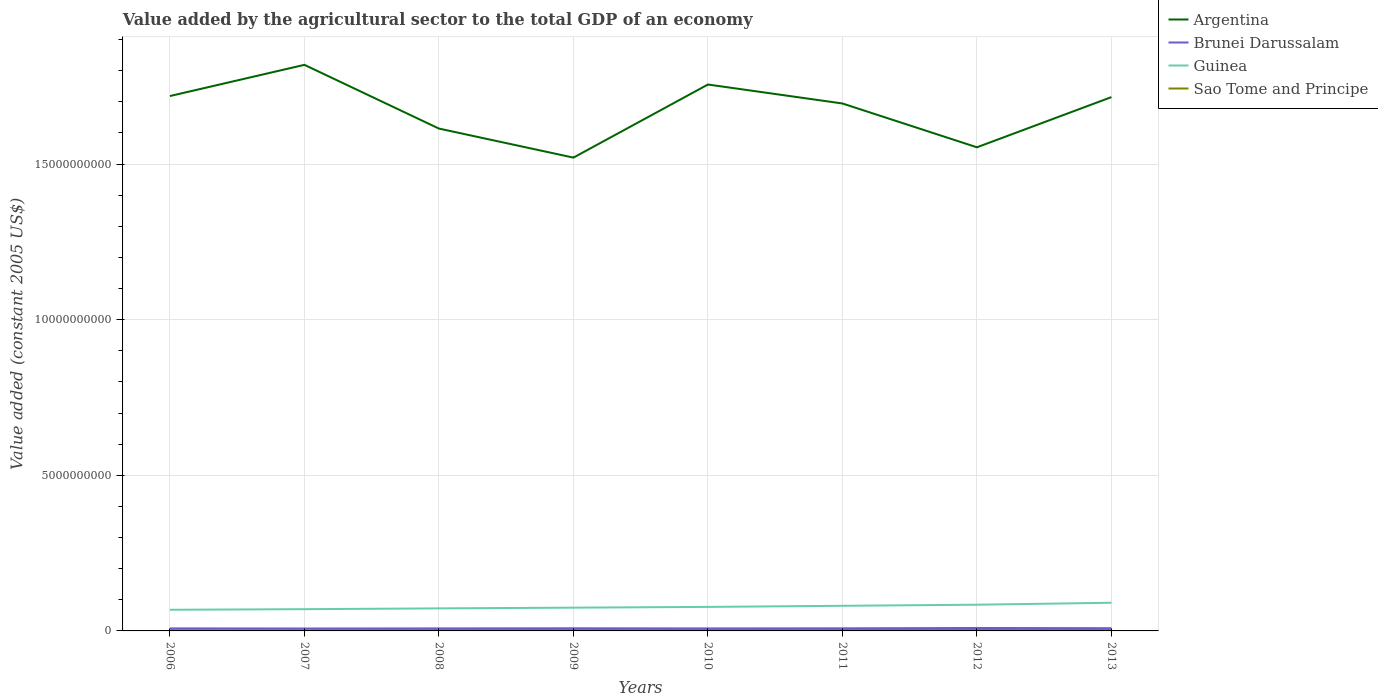Does the line corresponding to Argentina intersect with the line corresponding to Brunei Darussalam?
Keep it short and to the point. No. Across all years, what is the maximum value added by the agricultural sector in Argentina?
Make the answer very short. 1.52e+1. What is the total value added by the agricultural sector in Argentina in the graph?
Give a very brief answer. 1.04e+09. What is the difference between the highest and the second highest value added by the agricultural sector in Sao Tome and Principe?
Your response must be concise. 4.11e+06. How many lines are there?
Keep it short and to the point. 4. How many years are there in the graph?
Ensure brevity in your answer.  8. What is the difference between two consecutive major ticks on the Y-axis?
Your answer should be very brief. 5.00e+09. Are the values on the major ticks of Y-axis written in scientific E-notation?
Provide a succinct answer. No. How many legend labels are there?
Provide a short and direct response. 4. What is the title of the graph?
Provide a succinct answer. Value added by the agricultural sector to the total GDP of an economy. Does "Middle income" appear as one of the legend labels in the graph?
Provide a succinct answer. No. What is the label or title of the Y-axis?
Give a very brief answer. Value added (constant 2005 US$). What is the Value added (constant 2005 US$) in Argentina in 2006?
Give a very brief answer. 1.72e+1. What is the Value added (constant 2005 US$) in Brunei Darussalam in 2006?
Make the answer very short. 8.13e+07. What is the Value added (constant 2005 US$) of Guinea in 2006?
Make the answer very short. 6.80e+08. What is the Value added (constant 2005 US$) of Sao Tome and Principe in 2006?
Your answer should be very brief. 2.46e+07. What is the Value added (constant 2005 US$) in Argentina in 2007?
Offer a very short reply. 1.82e+1. What is the Value added (constant 2005 US$) of Brunei Darussalam in 2007?
Offer a very short reply. 7.77e+07. What is the Value added (constant 2005 US$) of Guinea in 2007?
Provide a short and direct response. 6.99e+08. What is the Value added (constant 2005 US$) of Sao Tome and Principe in 2007?
Offer a terse response. 2.53e+07. What is the Value added (constant 2005 US$) in Argentina in 2008?
Provide a succinct answer. 1.61e+1. What is the Value added (constant 2005 US$) in Brunei Darussalam in 2008?
Ensure brevity in your answer.  8.06e+07. What is the Value added (constant 2005 US$) in Guinea in 2008?
Keep it short and to the point. 7.24e+08. What is the Value added (constant 2005 US$) in Sao Tome and Principe in 2008?
Give a very brief answer. 2.75e+07. What is the Value added (constant 2005 US$) in Argentina in 2009?
Give a very brief answer. 1.52e+1. What is the Value added (constant 2005 US$) in Brunei Darussalam in 2009?
Ensure brevity in your answer.  8.52e+07. What is the Value added (constant 2005 US$) in Guinea in 2009?
Give a very brief answer. 7.48e+08. What is the Value added (constant 2005 US$) of Sao Tome and Principe in 2009?
Offer a very short reply. 2.85e+07. What is the Value added (constant 2005 US$) in Argentina in 2010?
Your answer should be compact. 1.76e+1. What is the Value added (constant 2005 US$) in Brunei Darussalam in 2010?
Give a very brief answer. 8.02e+07. What is the Value added (constant 2005 US$) in Guinea in 2010?
Your answer should be very brief. 7.71e+08. What is the Value added (constant 2005 US$) in Sao Tome and Principe in 2010?
Provide a succinct answer. 2.82e+07. What is the Value added (constant 2005 US$) of Argentina in 2011?
Provide a succinct answer. 1.69e+1. What is the Value added (constant 2005 US$) of Brunei Darussalam in 2011?
Your response must be concise. 8.39e+07. What is the Value added (constant 2005 US$) in Guinea in 2011?
Offer a terse response. 8.07e+08. What is the Value added (constant 2005 US$) of Sao Tome and Principe in 2011?
Keep it short and to the point. 2.85e+07. What is the Value added (constant 2005 US$) in Argentina in 2012?
Your answer should be compact. 1.55e+1. What is the Value added (constant 2005 US$) of Brunei Darussalam in 2012?
Provide a succinct answer. 9.38e+07. What is the Value added (constant 2005 US$) in Guinea in 2012?
Provide a succinct answer. 8.42e+08. What is the Value added (constant 2005 US$) of Sao Tome and Principe in 2012?
Provide a succinct answer. 2.85e+07. What is the Value added (constant 2005 US$) in Argentina in 2013?
Ensure brevity in your answer.  1.72e+1. What is the Value added (constant 2005 US$) of Brunei Darussalam in 2013?
Make the answer very short. 8.77e+07. What is the Value added (constant 2005 US$) of Guinea in 2013?
Ensure brevity in your answer.  9.05e+08. What is the Value added (constant 2005 US$) of Sao Tome and Principe in 2013?
Keep it short and to the point. 2.87e+07. Across all years, what is the maximum Value added (constant 2005 US$) in Argentina?
Give a very brief answer. 1.82e+1. Across all years, what is the maximum Value added (constant 2005 US$) in Brunei Darussalam?
Offer a very short reply. 9.38e+07. Across all years, what is the maximum Value added (constant 2005 US$) in Guinea?
Keep it short and to the point. 9.05e+08. Across all years, what is the maximum Value added (constant 2005 US$) of Sao Tome and Principe?
Provide a short and direct response. 2.87e+07. Across all years, what is the minimum Value added (constant 2005 US$) in Argentina?
Offer a very short reply. 1.52e+1. Across all years, what is the minimum Value added (constant 2005 US$) in Brunei Darussalam?
Offer a very short reply. 7.77e+07. Across all years, what is the minimum Value added (constant 2005 US$) of Guinea?
Provide a short and direct response. 6.80e+08. Across all years, what is the minimum Value added (constant 2005 US$) of Sao Tome and Principe?
Provide a succinct answer. 2.46e+07. What is the total Value added (constant 2005 US$) of Argentina in the graph?
Keep it short and to the point. 1.34e+11. What is the total Value added (constant 2005 US$) of Brunei Darussalam in the graph?
Provide a short and direct response. 6.70e+08. What is the total Value added (constant 2005 US$) in Guinea in the graph?
Keep it short and to the point. 6.18e+09. What is the total Value added (constant 2005 US$) of Sao Tome and Principe in the graph?
Give a very brief answer. 2.20e+08. What is the difference between the Value added (constant 2005 US$) of Argentina in 2006 and that in 2007?
Your response must be concise. -1.00e+09. What is the difference between the Value added (constant 2005 US$) in Brunei Darussalam in 2006 and that in 2007?
Provide a succinct answer. 3.63e+06. What is the difference between the Value added (constant 2005 US$) of Guinea in 2006 and that in 2007?
Provide a succinct answer. -1.90e+07. What is the difference between the Value added (constant 2005 US$) in Sao Tome and Principe in 2006 and that in 2007?
Provide a succinct answer. -6.63e+05. What is the difference between the Value added (constant 2005 US$) in Argentina in 2006 and that in 2008?
Make the answer very short. 1.05e+09. What is the difference between the Value added (constant 2005 US$) in Brunei Darussalam in 2006 and that in 2008?
Give a very brief answer. 7.27e+05. What is the difference between the Value added (constant 2005 US$) of Guinea in 2006 and that in 2008?
Give a very brief answer. -4.42e+07. What is the difference between the Value added (constant 2005 US$) of Sao Tome and Principe in 2006 and that in 2008?
Keep it short and to the point. -2.84e+06. What is the difference between the Value added (constant 2005 US$) in Argentina in 2006 and that in 2009?
Keep it short and to the point. 1.98e+09. What is the difference between the Value added (constant 2005 US$) of Brunei Darussalam in 2006 and that in 2009?
Your answer should be compact. -3.88e+06. What is the difference between the Value added (constant 2005 US$) of Guinea in 2006 and that in 2009?
Give a very brief answer. -6.76e+07. What is the difference between the Value added (constant 2005 US$) of Sao Tome and Principe in 2006 and that in 2009?
Your answer should be very brief. -3.91e+06. What is the difference between the Value added (constant 2005 US$) in Argentina in 2006 and that in 2010?
Your response must be concise. -3.70e+08. What is the difference between the Value added (constant 2005 US$) of Brunei Darussalam in 2006 and that in 2010?
Provide a short and direct response. 1.12e+06. What is the difference between the Value added (constant 2005 US$) in Guinea in 2006 and that in 2010?
Keep it short and to the point. -9.14e+07. What is the difference between the Value added (constant 2005 US$) in Sao Tome and Principe in 2006 and that in 2010?
Your response must be concise. -3.54e+06. What is the difference between the Value added (constant 2005 US$) of Argentina in 2006 and that in 2011?
Offer a very short reply. 2.39e+08. What is the difference between the Value added (constant 2005 US$) in Brunei Darussalam in 2006 and that in 2011?
Ensure brevity in your answer.  -2.54e+06. What is the difference between the Value added (constant 2005 US$) of Guinea in 2006 and that in 2011?
Provide a succinct answer. -1.27e+08. What is the difference between the Value added (constant 2005 US$) of Sao Tome and Principe in 2006 and that in 2011?
Offer a terse response. -3.83e+06. What is the difference between the Value added (constant 2005 US$) of Argentina in 2006 and that in 2012?
Your response must be concise. 1.65e+09. What is the difference between the Value added (constant 2005 US$) of Brunei Darussalam in 2006 and that in 2012?
Provide a short and direct response. -1.25e+07. What is the difference between the Value added (constant 2005 US$) of Guinea in 2006 and that in 2012?
Ensure brevity in your answer.  -1.62e+08. What is the difference between the Value added (constant 2005 US$) in Sao Tome and Principe in 2006 and that in 2012?
Your response must be concise. -3.83e+06. What is the difference between the Value added (constant 2005 US$) of Argentina in 2006 and that in 2013?
Your answer should be very brief. 3.43e+07. What is the difference between the Value added (constant 2005 US$) of Brunei Darussalam in 2006 and that in 2013?
Provide a short and direct response. -6.42e+06. What is the difference between the Value added (constant 2005 US$) in Guinea in 2006 and that in 2013?
Ensure brevity in your answer.  -2.25e+08. What is the difference between the Value added (constant 2005 US$) in Sao Tome and Principe in 2006 and that in 2013?
Make the answer very short. -4.11e+06. What is the difference between the Value added (constant 2005 US$) of Argentina in 2007 and that in 2008?
Ensure brevity in your answer.  2.05e+09. What is the difference between the Value added (constant 2005 US$) of Brunei Darussalam in 2007 and that in 2008?
Ensure brevity in your answer.  -2.91e+06. What is the difference between the Value added (constant 2005 US$) in Guinea in 2007 and that in 2008?
Your response must be concise. -2.52e+07. What is the difference between the Value added (constant 2005 US$) in Sao Tome and Principe in 2007 and that in 2008?
Keep it short and to the point. -2.17e+06. What is the difference between the Value added (constant 2005 US$) in Argentina in 2007 and that in 2009?
Ensure brevity in your answer.  2.98e+09. What is the difference between the Value added (constant 2005 US$) of Brunei Darussalam in 2007 and that in 2009?
Your answer should be compact. -7.51e+06. What is the difference between the Value added (constant 2005 US$) of Guinea in 2007 and that in 2009?
Provide a short and direct response. -4.85e+07. What is the difference between the Value added (constant 2005 US$) of Sao Tome and Principe in 2007 and that in 2009?
Keep it short and to the point. -3.25e+06. What is the difference between the Value added (constant 2005 US$) of Argentina in 2007 and that in 2010?
Your answer should be compact. 6.32e+08. What is the difference between the Value added (constant 2005 US$) of Brunei Darussalam in 2007 and that in 2010?
Offer a very short reply. -2.51e+06. What is the difference between the Value added (constant 2005 US$) of Guinea in 2007 and that in 2010?
Your answer should be very brief. -7.24e+07. What is the difference between the Value added (constant 2005 US$) in Sao Tome and Principe in 2007 and that in 2010?
Your answer should be very brief. -2.88e+06. What is the difference between the Value added (constant 2005 US$) of Argentina in 2007 and that in 2011?
Give a very brief answer. 1.24e+09. What is the difference between the Value added (constant 2005 US$) in Brunei Darussalam in 2007 and that in 2011?
Offer a terse response. -6.18e+06. What is the difference between the Value added (constant 2005 US$) of Guinea in 2007 and that in 2011?
Give a very brief answer. -1.08e+08. What is the difference between the Value added (constant 2005 US$) of Sao Tome and Principe in 2007 and that in 2011?
Give a very brief answer. -3.17e+06. What is the difference between the Value added (constant 2005 US$) of Argentina in 2007 and that in 2012?
Give a very brief answer. 2.65e+09. What is the difference between the Value added (constant 2005 US$) in Brunei Darussalam in 2007 and that in 2012?
Ensure brevity in your answer.  -1.61e+07. What is the difference between the Value added (constant 2005 US$) in Guinea in 2007 and that in 2012?
Offer a terse response. -1.43e+08. What is the difference between the Value added (constant 2005 US$) of Sao Tome and Principe in 2007 and that in 2012?
Your answer should be compact. -3.17e+06. What is the difference between the Value added (constant 2005 US$) in Argentina in 2007 and that in 2013?
Offer a terse response. 1.04e+09. What is the difference between the Value added (constant 2005 US$) in Brunei Darussalam in 2007 and that in 2013?
Make the answer very short. -1.01e+07. What is the difference between the Value added (constant 2005 US$) in Guinea in 2007 and that in 2013?
Give a very brief answer. -2.06e+08. What is the difference between the Value added (constant 2005 US$) in Sao Tome and Principe in 2007 and that in 2013?
Offer a terse response. -3.44e+06. What is the difference between the Value added (constant 2005 US$) of Argentina in 2008 and that in 2009?
Your answer should be very brief. 9.33e+08. What is the difference between the Value added (constant 2005 US$) of Brunei Darussalam in 2008 and that in 2009?
Your answer should be very brief. -4.60e+06. What is the difference between the Value added (constant 2005 US$) in Guinea in 2008 and that in 2009?
Keep it short and to the point. -2.34e+07. What is the difference between the Value added (constant 2005 US$) in Sao Tome and Principe in 2008 and that in 2009?
Keep it short and to the point. -1.07e+06. What is the difference between the Value added (constant 2005 US$) in Argentina in 2008 and that in 2010?
Your answer should be very brief. -1.42e+09. What is the difference between the Value added (constant 2005 US$) of Brunei Darussalam in 2008 and that in 2010?
Your response must be concise. 3.92e+05. What is the difference between the Value added (constant 2005 US$) in Guinea in 2008 and that in 2010?
Your answer should be compact. -4.72e+07. What is the difference between the Value added (constant 2005 US$) in Sao Tome and Principe in 2008 and that in 2010?
Your response must be concise. -7.05e+05. What is the difference between the Value added (constant 2005 US$) of Argentina in 2008 and that in 2011?
Give a very brief answer. -8.06e+08. What is the difference between the Value added (constant 2005 US$) in Brunei Darussalam in 2008 and that in 2011?
Your response must be concise. -3.27e+06. What is the difference between the Value added (constant 2005 US$) of Guinea in 2008 and that in 2011?
Ensure brevity in your answer.  -8.32e+07. What is the difference between the Value added (constant 2005 US$) of Sao Tome and Principe in 2008 and that in 2011?
Provide a succinct answer. -9.98e+05. What is the difference between the Value added (constant 2005 US$) in Argentina in 2008 and that in 2012?
Provide a succinct answer. 6.02e+08. What is the difference between the Value added (constant 2005 US$) of Brunei Darussalam in 2008 and that in 2012?
Offer a very short reply. -1.32e+07. What is the difference between the Value added (constant 2005 US$) of Guinea in 2008 and that in 2012?
Your response must be concise. -1.18e+08. What is the difference between the Value added (constant 2005 US$) of Sao Tome and Principe in 2008 and that in 2012?
Make the answer very short. -9.93e+05. What is the difference between the Value added (constant 2005 US$) in Argentina in 2008 and that in 2013?
Your answer should be very brief. -1.01e+09. What is the difference between the Value added (constant 2005 US$) of Brunei Darussalam in 2008 and that in 2013?
Make the answer very short. -7.15e+06. What is the difference between the Value added (constant 2005 US$) in Guinea in 2008 and that in 2013?
Ensure brevity in your answer.  -1.81e+08. What is the difference between the Value added (constant 2005 US$) in Sao Tome and Principe in 2008 and that in 2013?
Make the answer very short. -1.27e+06. What is the difference between the Value added (constant 2005 US$) in Argentina in 2009 and that in 2010?
Give a very brief answer. -2.35e+09. What is the difference between the Value added (constant 2005 US$) in Brunei Darussalam in 2009 and that in 2010?
Offer a terse response. 4.99e+06. What is the difference between the Value added (constant 2005 US$) in Guinea in 2009 and that in 2010?
Provide a short and direct response. -2.39e+07. What is the difference between the Value added (constant 2005 US$) of Sao Tome and Principe in 2009 and that in 2010?
Provide a succinct answer. 3.67e+05. What is the difference between the Value added (constant 2005 US$) in Argentina in 2009 and that in 2011?
Offer a terse response. -1.74e+09. What is the difference between the Value added (constant 2005 US$) of Brunei Darussalam in 2009 and that in 2011?
Your response must be concise. 1.33e+06. What is the difference between the Value added (constant 2005 US$) of Guinea in 2009 and that in 2011?
Offer a terse response. -5.98e+07. What is the difference between the Value added (constant 2005 US$) in Sao Tome and Principe in 2009 and that in 2011?
Make the answer very short. 7.39e+04. What is the difference between the Value added (constant 2005 US$) of Argentina in 2009 and that in 2012?
Provide a short and direct response. -3.31e+08. What is the difference between the Value added (constant 2005 US$) in Brunei Darussalam in 2009 and that in 2012?
Give a very brief answer. -8.60e+06. What is the difference between the Value added (constant 2005 US$) of Guinea in 2009 and that in 2012?
Provide a short and direct response. -9.49e+07. What is the difference between the Value added (constant 2005 US$) of Sao Tome and Principe in 2009 and that in 2012?
Your answer should be compact. 7.86e+04. What is the difference between the Value added (constant 2005 US$) in Argentina in 2009 and that in 2013?
Your response must be concise. -1.94e+09. What is the difference between the Value added (constant 2005 US$) of Brunei Darussalam in 2009 and that in 2013?
Offer a terse response. -2.54e+06. What is the difference between the Value added (constant 2005 US$) of Guinea in 2009 and that in 2013?
Provide a succinct answer. -1.57e+08. What is the difference between the Value added (constant 2005 US$) of Sao Tome and Principe in 2009 and that in 2013?
Your response must be concise. -1.99e+05. What is the difference between the Value added (constant 2005 US$) in Argentina in 2010 and that in 2011?
Your response must be concise. 6.09e+08. What is the difference between the Value added (constant 2005 US$) of Brunei Darussalam in 2010 and that in 2011?
Your answer should be compact. -3.66e+06. What is the difference between the Value added (constant 2005 US$) in Guinea in 2010 and that in 2011?
Provide a short and direct response. -3.59e+07. What is the difference between the Value added (constant 2005 US$) of Sao Tome and Principe in 2010 and that in 2011?
Make the answer very short. -2.93e+05. What is the difference between the Value added (constant 2005 US$) of Argentina in 2010 and that in 2012?
Ensure brevity in your answer.  2.02e+09. What is the difference between the Value added (constant 2005 US$) of Brunei Darussalam in 2010 and that in 2012?
Your answer should be very brief. -1.36e+07. What is the difference between the Value added (constant 2005 US$) in Guinea in 2010 and that in 2012?
Offer a terse response. -7.10e+07. What is the difference between the Value added (constant 2005 US$) of Sao Tome and Principe in 2010 and that in 2012?
Ensure brevity in your answer.  -2.89e+05. What is the difference between the Value added (constant 2005 US$) of Argentina in 2010 and that in 2013?
Your answer should be very brief. 4.05e+08. What is the difference between the Value added (constant 2005 US$) of Brunei Darussalam in 2010 and that in 2013?
Keep it short and to the point. -7.54e+06. What is the difference between the Value added (constant 2005 US$) in Guinea in 2010 and that in 2013?
Make the answer very short. -1.34e+08. What is the difference between the Value added (constant 2005 US$) of Sao Tome and Principe in 2010 and that in 2013?
Offer a very short reply. -5.66e+05. What is the difference between the Value added (constant 2005 US$) of Argentina in 2011 and that in 2012?
Provide a succinct answer. 1.41e+09. What is the difference between the Value added (constant 2005 US$) in Brunei Darussalam in 2011 and that in 2012?
Make the answer very short. -9.93e+06. What is the difference between the Value added (constant 2005 US$) in Guinea in 2011 and that in 2012?
Your answer should be compact. -3.51e+07. What is the difference between the Value added (constant 2005 US$) in Sao Tome and Principe in 2011 and that in 2012?
Give a very brief answer. 4665.81. What is the difference between the Value added (constant 2005 US$) of Argentina in 2011 and that in 2013?
Keep it short and to the point. -2.05e+08. What is the difference between the Value added (constant 2005 US$) in Brunei Darussalam in 2011 and that in 2013?
Offer a terse response. -3.88e+06. What is the difference between the Value added (constant 2005 US$) of Guinea in 2011 and that in 2013?
Ensure brevity in your answer.  -9.76e+07. What is the difference between the Value added (constant 2005 US$) in Sao Tome and Principe in 2011 and that in 2013?
Your answer should be compact. -2.73e+05. What is the difference between the Value added (constant 2005 US$) of Argentina in 2012 and that in 2013?
Your answer should be very brief. -1.61e+09. What is the difference between the Value added (constant 2005 US$) of Brunei Darussalam in 2012 and that in 2013?
Provide a succinct answer. 6.06e+06. What is the difference between the Value added (constant 2005 US$) in Guinea in 2012 and that in 2013?
Offer a very short reply. -6.25e+07. What is the difference between the Value added (constant 2005 US$) in Sao Tome and Principe in 2012 and that in 2013?
Give a very brief answer. -2.78e+05. What is the difference between the Value added (constant 2005 US$) of Argentina in 2006 and the Value added (constant 2005 US$) of Brunei Darussalam in 2007?
Make the answer very short. 1.71e+1. What is the difference between the Value added (constant 2005 US$) of Argentina in 2006 and the Value added (constant 2005 US$) of Guinea in 2007?
Your answer should be very brief. 1.65e+1. What is the difference between the Value added (constant 2005 US$) of Argentina in 2006 and the Value added (constant 2005 US$) of Sao Tome and Principe in 2007?
Offer a terse response. 1.72e+1. What is the difference between the Value added (constant 2005 US$) in Brunei Darussalam in 2006 and the Value added (constant 2005 US$) in Guinea in 2007?
Provide a short and direct response. -6.18e+08. What is the difference between the Value added (constant 2005 US$) of Brunei Darussalam in 2006 and the Value added (constant 2005 US$) of Sao Tome and Principe in 2007?
Ensure brevity in your answer.  5.60e+07. What is the difference between the Value added (constant 2005 US$) in Guinea in 2006 and the Value added (constant 2005 US$) in Sao Tome and Principe in 2007?
Keep it short and to the point. 6.55e+08. What is the difference between the Value added (constant 2005 US$) of Argentina in 2006 and the Value added (constant 2005 US$) of Brunei Darussalam in 2008?
Provide a short and direct response. 1.71e+1. What is the difference between the Value added (constant 2005 US$) of Argentina in 2006 and the Value added (constant 2005 US$) of Guinea in 2008?
Your response must be concise. 1.65e+1. What is the difference between the Value added (constant 2005 US$) in Argentina in 2006 and the Value added (constant 2005 US$) in Sao Tome and Principe in 2008?
Your answer should be very brief. 1.72e+1. What is the difference between the Value added (constant 2005 US$) of Brunei Darussalam in 2006 and the Value added (constant 2005 US$) of Guinea in 2008?
Your answer should be very brief. -6.43e+08. What is the difference between the Value added (constant 2005 US$) of Brunei Darussalam in 2006 and the Value added (constant 2005 US$) of Sao Tome and Principe in 2008?
Ensure brevity in your answer.  5.39e+07. What is the difference between the Value added (constant 2005 US$) in Guinea in 2006 and the Value added (constant 2005 US$) in Sao Tome and Principe in 2008?
Your answer should be compact. 6.53e+08. What is the difference between the Value added (constant 2005 US$) in Argentina in 2006 and the Value added (constant 2005 US$) in Brunei Darussalam in 2009?
Your answer should be very brief. 1.71e+1. What is the difference between the Value added (constant 2005 US$) of Argentina in 2006 and the Value added (constant 2005 US$) of Guinea in 2009?
Your response must be concise. 1.64e+1. What is the difference between the Value added (constant 2005 US$) of Argentina in 2006 and the Value added (constant 2005 US$) of Sao Tome and Principe in 2009?
Your answer should be very brief. 1.72e+1. What is the difference between the Value added (constant 2005 US$) of Brunei Darussalam in 2006 and the Value added (constant 2005 US$) of Guinea in 2009?
Your answer should be very brief. -6.66e+08. What is the difference between the Value added (constant 2005 US$) in Brunei Darussalam in 2006 and the Value added (constant 2005 US$) in Sao Tome and Principe in 2009?
Provide a short and direct response. 5.28e+07. What is the difference between the Value added (constant 2005 US$) in Guinea in 2006 and the Value added (constant 2005 US$) in Sao Tome and Principe in 2009?
Provide a succinct answer. 6.51e+08. What is the difference between the Value added (constant 2005 US$) of Argentina in 2006 and the Value added (constant 2005 US$) of Brunei Darussalam in 2010?
Your response must be concise. 1.71e+1. What is the difference between the Value added (constant 2005 US$) in Argentina in 2006 and the Value added (constant 2005 US$) in Guinea in 2010?
Provide a short and direct response. 1.64e+1. What is the difference between the Value added (constant 2005 US$) of Argentina in 2006 and the Value added (constant 2005 US$) of Sao Tome and Principe in 2010?
Keep it short and to the point. 1.72e+1. What is the difference between the Value added (constant 2005 US$) of Brunei Darussalam in 2006 and the Value added (constant 2005 US$) of Guinea in 2010?
Offer a very short reply. -6.90e+08. What is the difference between the Value added (constant 2005 US$) in Brunei Darussalam in 2006 and the Value added (constant 2005 US$) in Sao Tome and Principe in 2010?
Ensure brevity in your answer.  5.32e+07. What is the difference between the Value added (constant 2005 US$) in Guinea in 2006 and the Value added (constant 2005 US$) in Sao Tome and Principe in 2010?
Make the answer very short. 6.52e+08. What is the difference between the Value added (constant 2005 US$) of Argentina in 2006 and the Value added (constant 2005 US$) of Brunei Darussalam in 2011?
Offer a terse response. 1.71e+1. What is the difference between the Value added (constant 2005 US$) of Argentina in 2006 and the Value added (constant 2005 US$) of Guinea in 2011?
Give a very brief answer. 1.64e+1. What is the difference between the Value added (constant 2005 US$) of Argentina in 2006 and the Value added (constant 2005 US$) of Sao Tome and Principe in 2011?
Provide a short and direct response. 1.72e+1. What is the difference between the Value added (constant 2005 US$) in Brunei Darussalam in 2006 and the Value added (constant 2005 US$) in Guinea in 2011?
Your answer should be compact. -7.26e+08. What is the difference between the Value added (constant 2005 US$) of Brunei Darussalam in 2006 and the Value added (constant 2005 US$) of Sao Tome and Principe in 2011?
Your answer should be very brief. 5.29e+07. What is the difference between the Value added (constant 2005 US$) in Guinea in 2006 and the Value added (constant 2005 US$) in Sao Tome and Principe in 2011?
Give a very brief answer. 6.52e+08. What is the difference between the Value added (constant 2005 US$) of Argentina in 2006 and the Value added (constant 2005 US$) of Brunei Darussalam in 2012?
Give a very brief answer. 1.71e+1. What is the difference between the Value added (constant 2005 US$) in Argentina in 2006 and the Value added (constant 2005 US$) in Guinea in 2012?
Offer a terse response. 1.63e+1. What is the difference between the Value added (constant 2005 US$) in Argentina in 2006 and the Value added (constant 2005 US$) in Sao Tome and Principe in 2012?
Provide a short and direct response. 1.72e+1. What is the difference between the Value added (constant 2005 US$) in Brunei Darussalam in 2006 and the Value added (constant 2005 US$) in Guinea in 2012?
Offer a terse response. -7.61e+08. What is the difference between the Value added (constant 2005 US$) in Brunei Darussalam in 2006 and the Value added (constant 2005 US$) in Sao Tome and Principe in 2012?
Provide a short and direct response. 5.29e+07. What is the difference between the Value added (constant 2005 US$) in Guinea in 2006 and the Value added (constant 2005 US$) in Sao Tome and Principe in 2012?
Your response must be concise. 6.52e+08. What is the difference between the Value added (constant 2005 US$) in Argentina in 2006 and the Value added (constant 2005 US$) in Brunei Darussalam in 2013?
Your response must be concise. 1.71e+1. What is the difference between the Value added (constant 2005 US$) in Argentina in 2006 and the Value added (constant 2005 US$) in Guinea in 2013?
Provide a short and direct response. 1.63e+1. What is the difference between the Value added (constant 2005 US$) of Argentina in 2006 and the Value added (constant 2005 US$) of Sao Tome and Principe in 2013?
Your answer should be compact. 1.72e+1. What is the difference between the Value added (constant 2005 US$) of Brunei Darussalam in 2006 and the Value added (constant 2005 US$) of Guinea in 2013?
Give a very brief answer. -8.24e+08. What is the difference between the Value added (constant 2005 US$) of Brunei Darussalam in 2006 and the Value added (constant 2005 US$) of Sao Tome and Principe in 2013?
Offer a terse response. 5.26e+07. What is the difference between the Value added (constant 2005 US$) of Guinea in 2006 and the Value added (constant 2005 US$) of Sao Tome and Principe in 2013?
Give a very brief answer. 6.51e+08. What is the difference between the Value added (constant 2005 US$) in Argentina in 2007 and the Value added (constant 2005 US$) in Brunei Darussalam in 2008?
Make the answer very short. 1.81e+1. What is the difference between the Value added (constant 2005 US$) of Argentina in 2007 and the Value added (constant 2005 US$) of Guinea in 2008?
Your answer should be compact. 1.75e+1. What is the difference between the Value added (constant 2005 US$) in Argentina in 2007 and the Value added (constant 2005 US$) in Sao Tome and Principe in 2008?
Your answer should be compact. 1.82e+1. What is the difference between the Value added (constant 2005 US$) in Brunei Darussalam in 2007 and the Value added (constant 2005 US$) in Guinea in 2008?
Offer a terse response. -6.46e+08. What is the difference between the Value added (constant 2005 US$) in Brunei Darussalam in 2007 and the Value added (constant 2005 US$) in Sao Tome and Principe in 2008?
Make the answer very short. 5.02e+07. What is the difference between the Value added (constant 2005 US$) of Guinea in 2007 and the Value added (constant 2005 US$) of Sao Tome and Principe in 2008?
Give a very brief answer. 6.72e+08. What is the difference between the Value added (constant 2005 US$) in Argentina in 2007 and the Value added (constant 2005 US$) in Brunei Darussalam in 2009?
Your answer should be very brief. 1.81e+1. What is the difference between the Value added (constant 2005 US$) in Argentina in 2007 and the Value added (constant 2005 US$) in Guinea in 2009?
Provide a short and direct response. 1.74e+1. What is the difference between the Value added (constant 2005 US$) in Argentina in 2007 and the Value added (constant 2005 US$) in Sao Tome and Principe in 2009?
Provide a succinct answer. 1.82e+1. What is the difference between the Value added (constant 2005 US$) in Brunei Darussalam in 2007 and the Value added (constant 2005 US$) in Guinea in 2009?
Your response must be concise. -6.70e+08. What is the difference between the Value added (constant 2005 US$) in Brunei Darussalam in 2007 and the Value added (constant 2005 US$) in Sao Tome and Principe in 2009?
Make the answer very short. 4.92e+07. What is the difference between the Value added (constant 2005 US$) of Guinea in 2007 and the Value added (constant 2005 US$) of Sao Tome and Principe in 2009?
Ensure brevity in your answer.  6.70e+08. What is the difference between the Value added (constant 2005 US$) in Argentina in 2007 and the Value added (constant 2005 US$) in Brunei Darussalam in 2010?
Give a very brief answer. 1.81e+1. What is the difference between the Value added (constant 2005 US$) in Argentina in 2007 and the Value added (constant 2005 US$) in Guinea in 2010?
Your response must be concise. 1.74e+1. What is the difference between the Value added (constant 2005 US$) in Argentina in 2007 and the Value added (constant 2005 US$) in Sao Tome and Principe in 2010?
Make the answer very short. 1.82e+1. What is the difference between the Value added (constant 2005 US$) of Brunei Darussalam in 2007 and the Value added (constant 2005 US$) of Guinea in 2010?
Offer a terse response. -6.94e+08. What is the difference between the Value added (constant 2005 US$) of Brunei Darussalam in 2007 and the Value added (constant 2005 US$) of Sao Tome and Principe in 2010?
Make the answer very short. 4.95e+07. What is the difference between the Value added (constant 2005 US$) of Guinea in 2007 and the Value added (constant 2005 US$) of Sao Tome and Principe in 2010?
Ensure brevity in your answer.  6.71e+08. What is the difference between the Value added (constant 2005 US$) in Argentina in 2007 and the Value added (constant 2005 US$) in Brunei Darussalam in 2011?
Provide a short and direct response. 1.81e+1. What is the difference between the Value added (constant 2005 US$) in Argentina in 2007 and the Value added (constant 2005 US$) in Guinea in 2011?
Your answer should be very brief. 1.74e+1. What is the difference between the Value added (constant 2005 US$) in Argentina in 2007 and the Value added (constant 2005 US$) in Sao Tome and Principe in 2011?
Make the answer very short. 1.82e+1. What is the difference between the Value added (constant 2005 US$) in Brunei Darussalam in 2007 and the Value added (constant 2005 US$) in Guinea in 2011?
Offer a very short reply. -7.30e+08. What is the difference between the Value added (constant 2005 US$) of Brunei Darussalam in 2007 and the Value added (constant 2005 US$) of Sao Tome and Principe in 2011?
Ensure brevity in your answer.  4.92e+07. What is the difference between the Value added (constant 2005 US$) of Guinea in 2007 and the Value added (constant 2005 US$) of Sao Tome and Principe in 2011?
Provide a short and direct response. 6.71e+08. What is the difference between the Value added (constant 2005 US$) in Argentina in 2007 and the Value added (constant 2005 US$) in Brunei Darussalam in 2012?
Your response must be concise. 1.81e+1. What is the difference between the Value added (constant 2005 US$) of Argentina in 2007 and the Value added (constant 2005 US$) of Guinea in 2012?
Give a very brief answer. 1.73e+1. What is the difference between the Value added (constant 2005 US$) of Argentina in 2007 and the Value added (constant 2005 US$) of Sao Tome and Principe in 2012?
Provide a short and direct response. 1.82e+1. What is the difference between the Value added (constant 2005 US$) in Brunei Darussalam in 2007 and the Value added (constant 2005 US$) in Guinea in 2012?
Provide a short and direct response. -7.65e+08. What is the difference between the Value added (constant 2005 US$) in Brunei Darussalam in 2007 and the Value added (constant 2005 US$) in Sao Tome and Principe in 2012?
Make the answer very short. 4.92e+07. What is the difference between the Value added (constant 2005 US$) of Guinea in 2007 and the Value added (constant 2005 US$) of Sao Tome and Principe in 2012?
Offer a very short reply. 6.71e+08. What is the difference between the Value added (constant 2005 US$) in Argentina in 2007 and the Value added (constant 2005 US$) in Brunei Darussalam in 2013?
Offer a terse response. 1.81e+1. What is the difference between the Value added (constant 2005 US$) of Argentina in 2007 and the Value added (constant 2005 US$) of Guinea in 2013?
Make the answer very short. 1.73e+1. What is the difference between the Value added (constant 2005 US$) in Argentina in 2007 and the Value added (constant 2005 US$) in Sao Tome and Principe in 2013?
Provide a short and direct response. 1.82e+1. What is the difference between the Value added (constant 2005 US$) in Brunei Darussalam in 2007 and the Value added (constant 2005 US$) in Guinea in 2013?
Make the answer very short. -8.27e+08. What is the difference between the Value added (constant 2005 US$) in Brunei Darussalam in 2007 and the Value added (constant 2005 US$) in Sao Tome and Principe in 2013?
Provide a succinct answer. 4.90e+07. What is the difference between the Value added (constant 2005 US$) in Guinea in 2007 and the Value added (constant 2005 US$) in Sao Tome and Principe in 2013?
Your answer should be compact. 6.70e+08. What is the difference between the Value added (constant 2005 US$) of Argentina in 2008 and the Value added (constant 2005 US$) of Brunei Darussalam in 2009?
Your answer should be very brief. 1.61e+1. What is the difference between the Value added (constant 2005 US$) of Argentina in 2008 and the Value added (constant 2005 US$) of Guinea in 2009?
Make the answer very short. 1.54e+1. What is the difference between the Value added (constant 2005 US$) of Argentina in 2008 and the Value added (constant 2005 US$) of Sao Tome and Principe in 2009?
Your answer should be compact. 1.61e+1. What is the difference between the Value added (constant 2005 US$) of Brunei Darussalam in 2008 and the Value added (constant 2005 US$) of Guinea in 2009?
Make the answer very short. -6.67e+08. What is the difference between the Value added (constant 2005 US$) in Brunei Darussalam in 2008 and the Value added (constant 2005 US$) in Sao Tome and Principe in 2009?
Keep it short and to the point. 5.21e+07. What is the difference between the Value added (constant 2005 US$) of Guinea in 2008 and the Value added (constant 2005 US$) of Sao Tome and Principe in 2009?
Your answer should be compact. 6.96e+08. What is the difference between the Value added (constant 2005 US$) in Argentina in 2008 and the Value added (constant 2005 US$) in Brunei Darussalam in 2010?
Offer a terse response. 1.61e+1. What is the difference between the Value added (constant 2005 US$) in Argentina in 2008 and the Value added (constant 2005 US$) in Guinea in 2010?
Your answer should be very brief. 1.54e+1. What is the difference between the Value added (constant 2005 US$) in Argentina in 2008 and the Value added (constant 2005 US$) in Sao Tome and Principe in 2010?
Your answer should be very brief. 1.61e+1. What is the difference between the Value added (constant 2005 US$) of Brunei Darussalam in 2008 and the Value added (constant 2005 US$) of Guinea in 2010?
Ensure brevity in your answer.  -6.91e+08. What is the difference between the Value added (constant 2005 US$) of Brunei Darussalam in 2008 and the Value added (constant 2005 US$) of Sao Tome and Principe in 2010?
Provide a succinct answer. 5.24e+07. What is the difference between the Value added (constant 2005 US$) of Guinea in 2008 and the Value added (constant 2005 US$) of Sao Tome and Principe in 2010?
Provide a succinct answer. 6.96e+08. What is the difference between the Value added (constant 2005 US$) of Argentina in 2008 and the Value added (constant 2005 US$) of Brunei Darussalam in 2011?
Provide a short and direct response. 1.61e+1. What is the difference between the Value added (constant 2005 US$) in Argentina in 2008 and the Value added (constant 2005 US$) in Guinea in 2011?
Offer a very short reply. 1.53e+1. What is the difference between the Value added (constant 2005 US$) of Argentina in 2008 and the Value added (constant 2005 US$) of Sao Tome and Principe in 2011?
Offer a very short reply. 1.61e+1. What is the difference between the Value added (constant 2005 US$) in Brunei Darussalam in 2008 and the Value added (constant 2005 US$) in Guinea in 2011?
Offer a terse response. -7.27e+08. What is the difference between the Value added (constant 2005 US$) in Brunei Darussalam in 2008 and the Value added (constant 2005 US$) in Sao Tome and Principe in 2011?
Ensure brevity in your answer.  5.21e+07. What is the difference between the Value added (constant 2005 US$) in Guinea in 2008 and the Value added (constant 2005 US$) in Sao Tome and Principe in 2011?
Provide a short and direct response. 6.96e+08. What is the difference between the Value added (constant 2005 US$) in Argentina in 2008 and the Value added (constant 2005 US$) in Brunei Darussalam in 2012?
Give a very brief answer. 1.60e+1. What is the difference between the Value added (constant 2005 US$) of Argentina in 2008 and the Value added (constant 2005 US$) of Guinea in 2012?
Provide a short and direct response. 1.53e+1. What is the difference between the Value added (constant 2005 US$) of Argentina in 2008 and the Value added (constant 2005 US$) of Sao Tome and Principe in 2012?
Provide a succinct answer. 1.61e+1. What is the difference between the Value added (constant 2005 US$) of Brunei Darussalam in 2008 and the Value added (constant 2005 US$) of Guinea in 2012?
Your answer should be very brief. -7.62e+08. What is the difference between the Value added (constant 2005 US$) of Brunei Darussalam in 2008 and the Value added (constant 2005 US$) of Sao Tome and Principe in 2012?
Your answer should be very brief. 5.21e+07. What is the difference between the Value added (constant 2005 US$) in Guinea in 2008 and the Value added (constant 2005 US$) in Sao Tome and Principe in 2012?
Provide a short and direct response. 6.96e+08. What is the difference between the Value added (constant 2005 US$) in Argentina in 2008 and the Value added (constant 2005 US$) in Brunei Darussalam in 2013?
Your answer should be compact. 1.61e+1. What is the difference between the Value added (constant 2005 US$) of Argentina in 2008 and the Value added (constant 2005 US$) of Guinea in 2013?
Ensure brevity in your answer.  1.52e+1. What is the difference between the Value added (constant 2005 US$) in Argentina in 2008 and the Value added (constant 2005 US$) in Sao Tome and Principe in 2013?
Make the answer very short. 1.61e+1. What is the difference between the Value added (constant 2005 US$) in Brunei Darussalam in 2008 and the Value added (constant 2005 US$) in Guinea in 2013?
Give a very brief answer. -8.24e+08. What is the difference between the Value added (constant 2005 US$) in Brunei Darussalam in 2008 and the Value added (constant 2005 US$) in Sao Tome and Principe in 2013?
Ensure brevity in your answer.  5.19e+07. What is the difference between the Value added (constant 2005 US$) of Guinea in 2008 and the Value added (constant 2005 US$) of Sao Tome and Principe in 2013?
Your answer should be very brief. 6.95e+08. What is the difference between the Value added (constant 2005 US$) in Argentina in 2009 and the Value added (constant 2005 US$) in Brunei Darussalam in 2010?
Your answer should be very brief. 1.51e+1. What is the difference between the Value added (constant 2005 US$) of Argentina in 2009 and the Value added (constant 2005 US$) of Guinea in 2010?
Provide a succinct answer. 1.44e+1. What is the difference between the Value added (constant 2005 US$) in Argentina in 2009 and the Value added (constant 2005 US$) in Sao Tome and Principe in 2010?
Offer a very short reply. 1.52e+1. What is the difference between the Value added (constant 2005 US$) of Brunei Darussalam in 2009 and the Value added (constant 2005 US$) of Guinea in 2010?
Make the answer very short. -6.86e+08. What is the difference between the Value added (constant 2005 US$) in Brunei Darussalam in 2009 and the Value added (constant 2005 US$) in Sao Tome and Principe in 2010?
Offer a very short reply. 5.70e+07. What is the difference between the Value added (constant 2005 US$) of Guinea in 2009 and the Value added (constant 2005 US$) of Sao Tome and Principe in 2010?
Offer a very short reply. 7.19e+08. What is the difference between the Value added (constant 2005 US$) in Argentina in 2009 and the Value added (constant 2005 US$) in Brunei Darussalam in 2011?
Your answer should be very brief. 1.51e+1. What is the difference between the Value added (constant 2005 US$) of Argentina in 2009 and the Value added (constant 2005 US$) of Guinea in 2011?
Make the answer very short. 1.44e+1. What is the difference between the Value added (constant 2005 US$) of Argentina in 2009 and the Value added (constant 2005 US$) of Sao Tome and Principe in 2011?
Your response must be concise. 1.52e+1. What is the difference between the Value added (constant 2005 US$) of Brunei Darussalam in 2009 and the Value added (constant 2005 US$) of Guinea in 2011?
Your answer should be compact. -7.22e+08. What is the difference between the Value added (constant 2005 US$) of Brunei Darussalam in 2009 and the Value added (constant 2005 US$) of Sao Tome and Principe in 2011?
Offer a very short reply. 5.67e+07. What is the difference between the Value added (constant 2005 US$) in Guinea in 2009 and the Value added (constant 2005 US$) in Sao Tome and Principe in 2011?
Provide a succinct answer. 7.19e+08. What is the difference between the Value added (constant 2005 US$) in Argentina in 2009 and the Value added (constant 2005 US$) in Brunei Darussalam in 2012?
Your response must be concise. 1.51e+1. What is the difference between the Value added (constant 2005 US$) in Argentina in 2009 and the Value added (constant 2005 US$) in Guinea in 2012?
Ensure brevity in your answer.  1.44e+1. What is the difference between the Value added (constant 2005 US$) in Argentina in 2009 and the Value added (constant 2005 US$) in Sao Tome and Principe in 2012?
Your answer should be compact. 1.52e+1. What is the difference between the Value added (constant 2005 US$) of Brunei Darussalam in 2009 and the Value added (constant 2005 US$) of Guinea in 2012?
Make the answer very short. -7.57e+08. What is the difference between the Value added (constant 2005 US$) of Brunei Darussalam in 2009 and the Value added (constant 2005 US$) of Sao Tome and Principe in 2012?
Your response must be concise. 5.67e+07. What is the difference between the Value added (constant 2005 US$) of Guinea in 2009 and the Value added (constant 2005 US$) of Sao Tome and Principe in 2012?
Offer a terse response. 7.19e+08. What is the difference between the Value added (constant 2005 US$) of Argentina in 2009 and the Value added (constant 2005 US$) of Brunei Darussalam in 2013?
Your answer should be compact. 1.51e+1. What is the difference between the Value added (constant 2005 US$) in Argentina in 2009 and the Value added (constant 2005 US$) in Guinea in 2013?
Offer a very short reply. 1.43e+1. What is the difference between the Value added (constant 2005 US$) of Argentina in 2009 and the Value added (constant 2005 US$) of Sao Tome and Principe in 2013?
Make the answer very short. 1.52e+1. What is the difference between the Value added (constant 2005 US$) in Brunei Darussalam in 2009 and the Value added (constant 2005 US$) in Guinea in 2013?
Keep it short and to the point. -8.20e+08. What is the difference between the Value added (constant 2005 US$) in Brunei Darussalam in 2009 and the Value added (constant 2005 US$) in Sao Tome and Principe in 2013?
Your response must be concise. 5.65e+07. What is the difference between the Value added (constant 2005 US$) in Guinea in 2009 and the Value added (constant 2005 US$) in Sao Tome and Principe in 2013?
Your answer should be very brief. 7.19e+08. What is the difference between the Value added (constant 2005 US$) in Argentina in 2010 and the Value added (constant 2005 US$) in Brunei Darussalam in 2011?
Your answer should be very brief. 1.75e+1. What is the difference between the Value added (constant 2005 US$) in Argentina in 2010 and the Value added (constant 2005 US$) in Guinea in 2011?
Keep it short and to the point. 1.67e+1. What is the difference between the Value added (constant 2005 US$) of Argentina in 2010 and the Value added (constant 2005 US$) of Sao Tome and Principe in 2011?
Your answer should be compact. 1.75e+1. What is the difference between the Value added (constant 2005 US$) in Brunei Darussalam in 2010 and the Value added (constant 2005 US$) in Guinea in 2011?
Your response must be concise. -7.27e+08. What is the difference between the Value added (constant 2005 US$) in Brunei Darussalam in 2010 and the Value added (constant 2005 US$) in Sao Tome and Principe in 2011?
Ensure brevity in your answer.  5.17e+07. What is the difference between the Value added (constant 2005 US$) of Guinea in 2010 and the Value added (constant 2005 US$) of Sao Tome and Principe in 2011?
Provide a short and direct response. 7.43e+08. What is the difference between the Value added (constant 2005 US$) in Argentina in 2010 and the Value added (constant 2005 US$) in Brunei Darussalam in 2012?
Ensure brevity in your answer.  1.75e+1. What is the difference between the Value added (constant 2005 US$) in Argentina in 2010 and the Value added (constant 2005 US$) in Guinea in 2012?
Offer a terse response. 1.67e+1. What is the difference between the Value added (constant 2005 US$) in Argentina in 2010 and the Value added (constant 2005 US$) in Sao Tome and Principe in 2012?
Make the answer very short. 1.75e+1. What is the difference between the Value added (constant 2005 US$) of Brunei Darussalam in 2010 and the Value added (constant 2005 US$) of Guinea in 2012?
Your response must be concise. -7.62e+08. What is the difference between the Value added (constant 2005 US$) in Brunei Darussalam in 2010 and the Value added (constant 2005 US$) in Sao Tome and Principe in 2012?
Ensure brevity in your answer.  5.17e+07. What is the difference between the Value added (constant 2005 US$) of Guinea in 2010 and the Value added (constant 2005 US$) of Sao Tome and Principe in 2012?
Give a very brief answer. 7.43e+08. What is the difference between the Value added (constant 2005 US$) in Argentina in 2010 and the Value added (constant 2005 US$) in Brunei Darussalam in 2013?
Offer a very short reply. 1.75e+1. What is the difference between the Value added (constant 2005 US$) in Argentina in 2010 and the Value added (constant 2005 US$) in Guinea in 2013?
Provide a short and direct response. 1.67e+1. What is the difference between the Value added (constant 2005 US$) of Argentina in 2010 and the Value added (constant 2005 US$) of Sao Tome and Principe in 2013?
Your answer should be compact. 1.75e+1. What is the difference between the Value added (constant 2005 US$) of Brunei Darussalam in 2010 and the Value added (constant 2005 US$) of Guinea in 2013?
Make the answer very short. -8.25e+08. What is the difference between the Value added (constant 2005 US$) in Brunei Darussalam in 2010 and the Value added (constant 2005 US$) in Sao Tome and Principe in 2013?
Keep it short and to the point. 5.15e+07. What is the difference between the Value added (constant 2005 US$) in Guinea in 2010 and the Value added (constant 2005 US$) in Sao Tome and Principe in 2013?
Ensure brevity in your answer.  7.43e+08. What is the difference between the Value added (constant 2005 US$) in Argentina in 2011 and the Value added (constant 2005 US$) in Brunei Darussalam in 2012?
Keep it short and to the point. 1.69e+1. What is the difference between the Value added (constant 2005 US$) in Argentina in 2011 and the Value added (constant 2005 US$) in Guinea in 2012?
Make the answer very short. 1.61e+1. What is the difference between the Value added (constant 2005 US$) in Argentina in 2011 and the Value added (constant 2005 US$) in Sao Tome and Principe in 2012?
Your answer should be very brief. 1.69e+1. What is the difference between the Value added (constant 2005 US$) of Brunei Darussalam in 2011 and the Value added (constant 2005 US$) of Guinea in 2012?
Offer a terse response. -7.59e+08. What is the difference between the Value added (constant 2005 US$) in Brunei Darussalam in 2011 and the Value added (constant 2005 US$) in Sao Tome and Principe in 2012?
Your answer should be compact. 5.54e+07. What is the difference between the Value added (constant 2005 US$) of Guinea in 2011 and the Value added (constant 2005 US$) of Sao Tome and Principe in 2012?
Your answer should be very brief. 7.79e+08. What is the difference between the Value added (constant 2005 US$) in Argentina in 2011 and the Value added (constant 2005 US$) in Brunei Darussalam in 2013?
Your answer should be compact. 1.69e+1. What is the difference between the Value added (constant 2005 US$) of Argentina in 2011 and the Value added (constant 2005 US$) of Guinea in 2013?
Your response must be concise. 1.60e+1. What is the difference between the Value added (constant 2005 US$) of Argentina in 2011 and the Value added (constant 2005 US$) of Sao Tome and Principe in 2013?
Make the answer very short. 1.69e+1. What is the difference between the Value added (constant 2005 US$) of Brunei Darussalam in 2011 and the Value added (constant 2005 US$) of Guinea in 2013?
Give a very brief answer. -8.21e+08. What is the difference between the Value added (constant 2005 US$) in Brunei Darussalam in 2011 and the Value added (constant 2005 US$) in Sao Tome and Principe in 2013?
Your answer should be compact. 5.51e+07. What is the difference between the Value added (constant 2005 US$) in Guinea in 2011 and the Value added (constant 2005 US$) in Sao Tome and Principe in 2013?
Offer a very short reply. 7.79e+08. What is the difference between the Value added (constant 2005 US$) in Argentina in 2012 and the Value added (constant 2005 US$) in Brunei Darussalam in 2013?
Offer a terse response. 1.55e+1. What is the difference between the Value added (constant 2005 US$) in Argentina in 2012 and the Value added (constant 2005 US$) in Guinea in 2013?
Keep it short and to the point. 1.46e+1. What is the difference between the Value added (constant 2005 US$) of Argentina in 2012 and the Value added (constant 2005 US$) of Sao Tome and Principe in 2013?
Give a very brief answer. 1.55e+1. What is the difference between the Value added (constant 2005 US$) of Brunei Darussalam in 2012 and the Value added (constant 2005 US$) of Guinea in 2013?
Your answer should be compact. -8.11e+08. What is the difference between the Value added (constant 2005 US$) of Brunei Darussalam in 2012 and the Value added (constant 2005 US$) of Sao Tome and Principe in 2013?
Offer a terse response. 6.51e+07. What is the difference between the Value added (constant 2005 US$) of Guinea in 2012 and the Value added (constant 2005 US$) of Sao Tome and Principe in 2013?
Offer a very short reply. 8.14e+08. What is the average Value added (constant 2005 US$) in Argentina per year?
Give a very brief answer. 1.67e+1. What is the average Value added (constant 2005 US$) in Brunei Darussalam per year?
Provide a short and direct response. 8.38e+07. What is the average Value added (constant 2005 US$) of Guinea per year?
Your answer should be very brief. 7.72e+08. What is the average Value added (constant 2005 US$) in Sao Tome and Principe per year?
Your response must be concise. 2.75e+07. In the year 2006, what is the difference between the Value added (constant 2005 US$) of Argentina and Value added (constant 2005 US$) of Brunei Darussalam?
Your response must be concise. 1.71e+1. In the year 2006, what is the difference between the Value added (constant 2005 US$) of Argentina and Value added (constant 2005 US$) of Guinea?
Offer a very short reply. 1.65e+1. In the year 2006, what is the difference between the Value added (constant 2005 US$) in Argentina and Value added (constant 2005 US$) in Sao Tome and Principe?
Provide a short and direct response. 1.72e+1. In the year 2006, what is the difference between the Value added (constant 2005 US$) in Brunei Darussalam and Value added (constant 2005 US$) in Guinea?
Keep it short and to the point. -5.99e+08. In the year 2006, what is the difference between the Value added (constant 2005 US$) of Brunei Darussalam and Value added (constant 2005 US$) of Sao Tome and Principe?
Offer a terse response. 5.67e+07. In the year 2006, what is the difference between the Value added (constant 2005 US$) in Guinea and Value added (constant 2005 US$) in Sao Tome and Principe?
Provide a short and direct response. 6.55e+08. In the year 2007, what is the difference between the Value added (constant 2005 US$) in Argentina and Value added (constant 2005 US$) in Brunei Darussalam?
Offer a very short reply. 1.81e+1. In the year 2007, what is the difference between the Value added (constant 2005 US$) of Argentina and Value added (constant 2005 US$) of Guinea?
Offer a terse response. 1.75e+1. In the year 2007, what is the difference between the Value added (constant 2005 US$) of Argentina and Value added (constant 2005 US$) of Sao Tome and Principe?
Your answer should be compact. 1.82e+1. In the year 2007, what is the difference between the Value added (constant 2005 US$) in Brunei Darussalam and Value added (constant 2005 US$) in Guinea?
Offer a very short reply. -6.21e+08. In the year 2007, what is the difference between the Value added (constant 2005 US$) of Brunei Darussalam and Value added (constant 2005 US$) of Sao Tome and Principe?
Make the answer very short. 5.24e+07. In the year 2007, what is the difference between the Value added (constant 2005 US$) in Guinea and Value added (constant 2005 US$) in Sao Tome and Principe?
Your answer should be very brief. 6.74e+08. In the year 2008, what is the difference between the Value added (constant 2005 US$) of Argentina and Value added (constant 2005 US$) of Brunei Darussalam?
Your answer should be very brief. 1.61e+1. In the year 2008, what is the difference between the Value added (constant 2005 US$) in Argentina and Value added (constant 2005 US$) in Guinea?
Offer a terse response. 1.54e+1. In the year 2008, what is the difference between the Value added (constant 2005 US$) in Argentina and Value added (constant 2005 US$) in Sao Tome and Principe?
Keep it short and to the point. 1.61e+1. In the year 2008, what is the difference between the Value added (constant 2005 US$) in Brunei Darussalam and Value added (constant 2005 US$) in Guinea?
Ensure brevity in your answer.  -6.44e+08. In the year 2008, what is the difference between the Value added (constant 2005 US$) of Brunei Darussalam and Value added (constant 2005 US$) of Sao Tome and Principe?
Make the answer very short. 5.31e+07. In the year 2008, what is the difference between the Value added (constant 2005 US$) in Guinea and Value added (constant 2005 US$) in Sao Tome and Principe?
Make the answer very short. 6.97e+08. In the year 2009, what is the difference between the Value added (constant 2005 US$) of Argentina and Value added (constant 2005 US$) of Brunei Darussalam?
Give a very brief answer. 1.51e+1. In the year 2009, what is the difference between the Value added (constant 2005 US$) in Argentina and Value added (constant 2005 US$) in Guinea?
Offer a terse response. 1.45e+1. In the year 2009, what is the difference between the Value added (constant 2005 US$) in Argentina and Value added (constant 2005 US$) in Sao Tome and Principe?
Your response must be concise. 1.52e+1. In the year 2009, what is the difference between the Value added (constant 2005 US$) of Brunei Darussalam and Value added (constant 2005 US$) of Guinea?
Keep it short and to the point. -6.62e+08. In the year 2009, what is the difference between the Value added (constant 2005 US$) in Brunei Darussalam and Value added (constant 2005 US$) in Sao Tome and Principe?
Offer a very short reply. 5.67e+07. In the year 2009, what is the difference between the Value added (constant 2005 US$) in Guinea and Value added (constant 2005 US$) in Sao Tome and Principe?
Keep it short and to the point. 7.19e+08. In the year 2010, what is the difference between the Value added (constant 2005 US$) in Argentina and Value added (constant 2005 US$) in Brunei Darussalam?
Make the answer very short. 1.75e+1. In the year 2010, what is the difference between the Value added (constant 2005 US$) of Argentina and Value added (constant 2005 US$) of Guinea?
Offer a very short reply. 1.68e+1. In the year 2010, what is the difference between the Value added (constant 2005 US$) of Argentina and Value added (constant 2005 US$) of Sao Tome and Principe?
Provide a succinct answer. 1.75e+1. In the year 2010, what is the difference between the Value added (constant 2005 US$) in Brunei Darussalam and Value added (constant 2005 US$) in Guinea?
Provide a succinct answer. -6.91e+08. In the year 2010, what is the difference between the Value added (constant 2005 US$) in Brunei Darussalam and Value added (constant 2005 US$) in Sao Tome and Principe?
Offer a very short reply. 5.20e+07. In the year 2010, what is the difference between the Value added (constant 2005 US$) of Guinea and Value added (constant 2005 US$) of Sao Tome and Principe?
Make the answer very short. 7.43e+08. In the year 2011, what is the difference between the Value added (constant 2005 US$) in Argentina and Value added (constant 2005 US$) in Brunei Darussalam?
Offer a terse response. 1.69e+1. In the year 2011, what is the difference between the Value added (constant 2005 US$) of Argentina and Value added (constant 2005 US$) of Guinea?
Your answer should be compact. 1.61e+1. In the year 2011, what is the difference between the Value added (constant 2005 US$) in Argentina and Value added (constant 2005 US$) in Sao Tome and Principe?
Make the answer very short. 1.69e+1. In the year 2011, what is the difference between the Value added (constant 2005 US$) in Brunei Darussalam and Value added (constant 2005 US$) in Guinea?
Offer a terse response. -7.23e+08. In the year 2011, what is the difference between the Value added (constant 2005 US$) in Brunei Darussalam and Value added (constant 2005 US$) in Sao Tome and Principe?
Ensure brevity in your answer.  5.54e+07. In the year 2011, what is the difference between the Value added (constant 2005 US$) of Guinea and Value added (constant 2005 US$) of Sao Tome and Principe?
Make the answer very short. 7.79e+08. In the year 2012, what is the difference between the Value added (constant 2005 US$) of Argentina and Value added (constant 2005 US$) of Brunei Darussalam?
Make the answer very short. 1.54e+1. In the year 2012, what is the difference between the Value added (constant 2005 US$) in Argentina and Value added (constant 2005 US$) in Guinea?
Make the answer very short. 1.47e+1. In the year 2012, what is the difference between the Value added (constant 2005 US$) of Argentina and Value added (constant 2005 US$) of Sao Tome and Principe?
Your answer should be very brief. 1.55e+1. In the year 2012, what is the difference between the Value added (constant 2005 US$) in Brunei Darussalam and Value added (constant 2005 US$) in Guinea?
Keep it short and to the point. -7.49e+08. In the year 2012, what is the difference between the Value added (constant 2005 US$) in Brunei Darussalam and Value added (constant 2005 US$) in Sao Tome and Principe?
Provide a succinct answer. 6.53e+07. In the year 2012, what is the difference between the Value added (constant 2005 US$) of Guinea and Value added (constant 2005 US$) of Sao Tome and Principe?
Your answer should be compact. 8.14e+08. In the year 2013, what is the difference between the Value added (constant 2005 US$) of Argentina and Value added (constant 2005 US$) of Brunei Darussalam?
Provide a succinct answer. 1.71e+1. In the year 2013, what is the difference between the Value added (constant 2005 US$) in Argentina and Value added (constant 2005 US$) in Guinea?
Keep it short and to the point. 1.62e+1. In the year 2013, what is the difference between the Value added (constant 2005 US$) in Argentina and Value added (constant 2005 US$) in Sao Tome and Principe?
Offer a terse response. 1.71e+1. In the year 2013, what is the difference between the Value added (constant 2005 US$) in Brunei Darussalam and Value added (constant 2005 US$) in Guinea?
Your answer should be very brief. -8.17e+08. In the year 2013, what is the difference between the Value added (constant 2005 US$) in Brunei Darussalam and Value added (constant 2005 US$) in Sao Tome and Principe?
Provide a short and direct response. 5.90e+07. In the year 2013, what is the difference between the Value added (constant 2005 US$) in Guinea and Value added (constant 2005 US$) in Sao Tome and Principe?
Offer a terse response. 8.76e+08. What is the ratio of the Value added (constant 2005 US$) in Argentina in 2006 to that in 2007?
Offer a terse response. 0.94. What is the ratio of the Value added (constant 2005 US$) in Brunei Darussalam in 2006 to that in 2007?
Provide a short and direct response. 1.05. What is the ratio of the Value added (constant 2005 US$) in Guinea in 2006 to that in 2007?
Your answer should be compact. 0.97. What is the ratio of the Value added (constant 2005 US$) of Sao Tome and Principe in 2006 to that in 2007?
Offer a terse response. 0.97. What is the ratio of the Value added (constant 2005 US$) in Argentina in 2006 to that in 2008?
Provide a short and direct response. 1.06. What is the ratio of the Value added (constant 2005 US$) in Guinea in 2006 to that in 2008?
Give a very brief answer. 0.94. What is the ratio of the Value added (constant 2005 US$) in Sao Tome and Principe in 2006 to that in 2008?
Your response must be concise. 0.9. What is the ratio of the Value added (constant 2005 US$) in Argentina in 2006 to that in 2009?
Offer a terse response. 1.13. What is the ratio of the Value added (constant 2005 US$) of Brunei Darussalam in 2006 to that in 2009?
Make the answer very short. 0.95. What is the ratio of the Value added (constant 2005 US$) in Guinea in 2006 to that in 2009?
Keep it short and to the point. 0.91. What is the ratio of the Value added (constant 2005 US$) of Sao Tome and Principe in 2006 to that in 2009?
Your response must be concise. 0.86. What is the ratio of the Value added (constant 2005 US$) in Argentina in 2006 to that in 2010?
Ensure brevity in your answer.  0.98. What is the ratio of the Value added (constant 2005 US$) of Brunei Darussalam in 2006 to that in 2010?
Make the answer very short. 1.01. What is the ratio of the Value added (constant 2005 US$) of Guinea in 2006 to that in 2010?
Offer a terse response. 0.88. What is the ratio of the Value added (constant 2005 US$) in Sao Tome and Principe in 2006 to that in 2010?
Give a very brief answer. 0.87. What is the ratio of the Value added (constant 2005 US$) of Argentina in 2006 to that in 2011?
Your response must be concise. 1.01. What is the ratio of the Value added (constant 2005 US$) in Brunei Darussalam in 2006 to that in 2011?
Offer a very short reply. 0.97. What is the ratio of the Value added (constant 2005 US$) of Guinea in 2006 to that in 2011?
Provide a short and direct response. 0.84. What is the ratio of the Value added (constant 2005 US$) of Sao Tome and Principe in 2006 to that in 2011?
Your answer should be very brief. 0.87. What is the ratio of the Value added (constant 2005 US$) in Argentina in 2006 to that in 2012?
Give a very brief answer. 1.11. What is the ratio of the Value added (constant 2005 US$) in Brunei Darussalam in 2006 to that in 2012?
Make the answer very short. 0.87. What is the ratio of the Value added (constant 2005 US$) in Guinea in 2006 to that in 2012?
Provide a short and direct response. 0.81. What is the ratio of the Value added (constant 2005 US$) of Sao Tome and Principe in 2006 to that in 2012?
Ensure brevity in your answer.  0.87. What is the ratio of the Value added (constant 2005 US$) in Brunei Darussalam in 2006 to that in 2013?
Make the answer very short. 0.93. What is the ratio of the Value added (constant 2005 US$) in Guinea in 2006 to that in 2013?
Your answer should be very brief. 0.75. What is the ratio of the Value added (constant 2005 US$) of Sao Tome and Principe in 2006 to that in 2013?
Make the answer very short. 0.86. What is the ratio of the Value added (constant 2005 US$) in Argentina in 2007 to that in 2008?
Offer a terse response. 1.13. What is the ratio of the Value added (constant 2005 US$) of Brunei Darussalam in 2007 to that in 2008?
Provide a short and direct response. 0.96. What is the ratio of the Value added (constant 2005 US$) in Guinea in 2007 to that in 2008?
Offer a terse response. 0.97. What is the ratio of the Value added (constant 2005 US$) of Sao Tome and Principe in 2007 to that in 2008?
Provide a short and direct response. 0.92. What is the ratio of the Value added (constant 2005 US$) in Argentina in 2007 to that in 2009?
Ensure brevity in your answer.  1.2. What is the ratio of the Value added (constant 2005 US$) in Brunei Darussalam in 2007 to that in 2009?
Your response must be concise. 0.91. What is the ratio of the Value added (constant 2005 US$) in Guinea in 2007 to that in 2009?
Your answer should be compact. 0.94. What is the ratio of the Value added (constant 2005 US$) of Sao Tome and Principe in 2007 to that in 2009?
Ensure brevity in your answer.  0.89. What is the ratio of the Value added (constant 2005 US$) of Argentina in 2007 to that in 2010?
Ensure brevity in your answer.  1.04. What is the ratio of the Value added (constant 2005 US$) in Brunei Darussalam in 2007 to that in 2010?
Provide a short and direct response. 0.97. What is the ratio of the Value added (constant 2005 US$) of Guinea in 2007 to that in 2010?
Offer a terse response. 0.91. What is the ratio of the Value added (constant 2005 US$) of Sao Tome and Principe in 2007 to that in 2010?
Offer a terse response. 0.9. What is the ratio of the Value added (constant 2005 US$) in Argentina in 2007 to that in 2011?
Ensure brevity in your answer.  1.07. What is the ratio of the Value added (constant 2005 US$) in Brunei Darussalam in 2007 to that in 2011?
Your response must be concise. 0.93. What is the ratio of the Value added (constant 2005 US$) of Guinea in 2007 to that in 2011?
Offer a very short reply. 0.87. What is the ratio of the Value added (constant 2005 US$) in Sao Tome and Principe in 2007 to that in 2011?
Ensure brevity in your answer.  0.89. What is the ratio of the Value added (constant 2005 US$) in Argentina in 2007 to that in 2012?
Give a very brief answer. 1.17. What is the ratio of the Value added (constant 2005 US$) of Brunei Darussalam in 2007 to that in 2012?
Provide a succinct answer. 0.83. What is the ratio of the Value added (constant 2005 US$) in Guinea in 2007 to that in 2012?
Your answer should be very brief. 0.83. What is the ratio of the Value added (constant 2005 US$) in Sao Tome and Principe in 2007 to that in 2012?
Your response must be concise. 0.89. What is the ratio of the Value added (constant 2005 US$) of Argentina in 2007 to that in 2013?
Keep it short and to the point. 1.06. What is the ratio of the Value added (constant 2005 US$) of Brunei Darussalam in 2007 to that in 2013?
Make the answer very short. 0.89. What is the ratio of the Value added (constant 2005 US$) in Guinea in 2007 to that in 2013?
Offer a terse response. 0.77. What is the ratio of the Value added (constant 2005 US$) of Sao Tome and Principe in 2007 to that in 2013?
Your response must be concise. 0.88. What is the ratio of the Value added (constant 2005 US$) in Argentina in 2008 to that in 2009?
Your response must be concise. 1.06. What is the ratio of the Value added (constant 2005 US$) of Brunei Darussalam in 2008 to that in 2009?
Keep it short and to the point. 0.95. What is the ratio of the Value added (constant 2005 US$) in Guinea in 2008 to that in 2009?
Provide a short and direct response. 0.97. What is the ratio of the Value added (constant 2005 US$) in Sao Tome and Principe in 2008 to that in 2009?
Your answer should be very brief. 0.96. What is the ratio of the Value added (constant 2005 US$) in Argentina in 2008 to that in 2010?
Ensure brevity in your answer.  0.92. What is the ratio of the Value added (constant 2005 US$) of Guinea in 2008 to that in 2010?
Provide a succinct answer. 0.94. What is the ratio of the Value added (constant 2005 US$) of Brunei Darussalam in 2008 to that in 2011?
Ensure brevity in your answer.  0.96. What is the ratio of the Value added (constant 2005 US$) in Guinea in 2008 to that in 2011?
Make the answer very short. 0.9. What is the ratio of the Value added (constant 2005 US$) of Sao Tome and Principe in 2008 to that in 2011?
Your response must be concise. 0.96. What is the ratio of the Value added (constant 2005 US$) in Argentina in 2008 to that in 2012?
Offer a terse response. 1.04. What is the ratio of the Value added (constant 2005 US$) in Brunei Darussalam in 2008 to that in 2012?
Your response must be concise. 0.86. What is the ratio of the Value added (constant 2005 US$) of Guinea in 2008 to that in 2012?
Your answer should be compact. 0.86. What is the ratio of the Value added (constant 2005 US$) of Sao Tome and Principe in 2008 to that in 2012?
Provide a short and direct response. 0.97. What is the ratio of the Value added (constant 2005 US$) in Argentina in 2008 to that in 2013?
Provide a short and direct response. 0.94. What is the ratio of the Value added (constant 2005 US$) in Brunei Darussalam in 2008 to that in 2013?
Make the answer very short. 0.92. What is the ratio of the Value added (constant 2005 US$) in Guinea in 2008 to that in 2013?
Offer a very short reply. 0.8. What is the ratio of the Value added (constant 2005 US$) of Sao Tome and Principe in 2008 to that in 2013?
Give a very brief answer. 0.96. What is the ratio of the Value added (constant 2005 US$) in Argentina in 2009 to that in 2010?
Give a very brief answer. 0.87. What is the ratio of the Value added (constant 2005 US$) of Brunei Darussalam in 2009 to that in 2010?
Offer a terse response. 1.06. What is the ratio of the Value added (constant 2005 US$) of Guinea in 2009 to that in 2010?
Provide a short and direct response. 0.97. What is the ratio of the Value added (constant 2005 US$) of Sao Tome and Principe in 2009 to that in 2010?
Offer a terse response. 1.01. What is the ratio of the Value added (constant 2005 US$) of Argentina in 2009 to that in 2011?
Offer a very short reply. 0.9. What is the ratio of the Value added (constant 2005 US$) in Brunei Darussalam in 2009 to that in 2011?
Make the answer very short. 1.02. What is the ratio of the Value added (constant 2005 US$) in Guinea in 2009 to that in 2011?
Provide a short and direct response. 0.93. What is the ratio of the Value added (constant 2005 US$) of Argentina in 2009 to that in 2012?
Make the answer very short. 0.98. What is the ratio of the Value added (constant 2005 US$) of Brunei Darussalam in 2009 to that in 2012?
Provide a short and direct response. 0.91. What is the ratio of the Value added (constant 2005 US$) of Guinea in 2009 to that in 2012?
Offer a very short reply. 0.89. What is the ratio of the Value added (constant 2005 US$) in Argentina in 2009 to that in 2013?
Offer a very short reply. 0.89. What is the ratio of the Value added (constant 2005 US$) in Guinea in 2009 to that in 2013?
Ensure brevity in your answer.  0.83. What is the ratio of the Value added (constant 2005 US$) in Sao Tome and Principe in 2009 to that in 2013?
Your answer should be compact. 0.99. What is the ratio of the Value added (constant 2005 US$) of Argentina in 2010 to that in 2011?
Offer a terse response. 1.04. What is the ratio of the Value added (constant 2005 US$) of Brunei Darussalam in 2010 to that in 2011?
Your answer should be very brief. 0.96. What is the ratio of the Value added (constant 2005 US$) in Guinea in 2010 to that in 2011?
Offer a very short reply. 0.96. What is the ratio of the Value added (constant 2005 US$) in Sao Tome and Principe in 2010 to that in 2011?
Provide a short and direct response. 0.99. What is the ratio of the Value added (constant 2005 US$) of Argentina in 2010 to that in 2012?
Make the answer very short. 1.13. What is the ratio of the Value added (constant 2005 US$) in Brunei Darussalam in 2010 to that in 2012?
Provide a short and direct response. 0.86. What is the ratio of the Value added (constant 2005 US$) in Guinea in 2010 to that in 2012?
Offer a very short reply. 0.92. What is the ratio of the Value added (constant 2005 US$) of Argentina in 2010 to that in 2013?
Keep it short and to the point. 1.02. What is the ratio of the Value added (constant 2005 US$) in Brunei Darussalam in 2010 to that in 2013?
Your answer should be compact. 0.91. What is the ratio of the Value added (constant 2005 US$) in Guinea in 2010 to that in 2013?
Ensure brevity in your answer.  0.85. What is the ratio of the Value added (constant 2005 US$) in Sao Tome and Principe in 2010 to that in 2013?
Keep it short and to the point. 0.98. What is the ratio of the Value added (constant 2005 US$) in Argentina in 2011 to that in 2012?
Offer a terse response. 1.09. What is the ratio of the Value added (constant 2005 US$) in Brunei Darussalam in 2011 to that in 2012?
Your response must be concise. 0.89. What is the ratio of the Value added (constant 2005 US$) of Sao Tome and Principe in 2011 to that in 2012?
Provide a succinct answer. 1. What is the ratio of the Value added (constant 2005 US$) of Argentina in 2011 to that in 2013?
Keep it short and to the point. 0.99. What is the ratio of the Value added (constant 2005 US$) of Brunei Darussalam in 2011 to that in 2013?
Ensure brevity in your answer.  0.96. What is the ratio of the Value added (constant 2005 US$) of Guinea in 2011 to that in 2013?
Provide a succinct answer. 0.89. What is the ratio of the Value added (constant 2005 US$) of Argentina in 2012 to that in 2013?
Your answer should be very brief. 0.91. What is the ratio of the Value added (constant 2005 US$) in Brunei Darussalam in 2012 to that in 2013?
Provide a succinct answer. 1.07. What is the ratio of the Value added (constant 2005 US$) of Guinea in 2012 to that in 2013?
Make the answer very short. 0.93. What is the ratio of the Value added (constant 2005 US$) of Sao Tome and Principe in 2012 to that in 2013?
Ensure brevity in your answer.  0.99. What is the difference between the highest and the second highest Value added (constant 2005 US$) of Argentina?
Your answer should be compact. 6.32e+08. What is the difference between the highest and the second highest Value added (constant 2005 US$) in Brunei Darussalam?
Your answer should be compact. 6.06e+06. What is the difference between the highest and the second highest Value added (constant 2005 US$) in Guinea?
Provide a short and direct response. 6.25e+07. What is the difference between the highest and the second highest Value added (constant 2005 US$) of Sao Tome and Principe?
Your answer should be very brief. 1.99e+05. What is the difference between the highest and the lowest Value added (constant 2005 US$) of Argentina?
Provide a succinct answer. 2.98e+09. What is the difference between the highest and the lowest Value added (constant 2005 US$) in Brunei Darussalam?
Provide a short and direct response. 1.61e+07. What is the difference between the highest and the lowest Value added (constant 2005 US$) of Guinea?
Your answer should be compact. 2.25e+08. What is the difference between the highest and the lowest Value added (constant 2005 US$) of Sao Tome and Principe?
Your answer should be compact. 4.11e+06. 